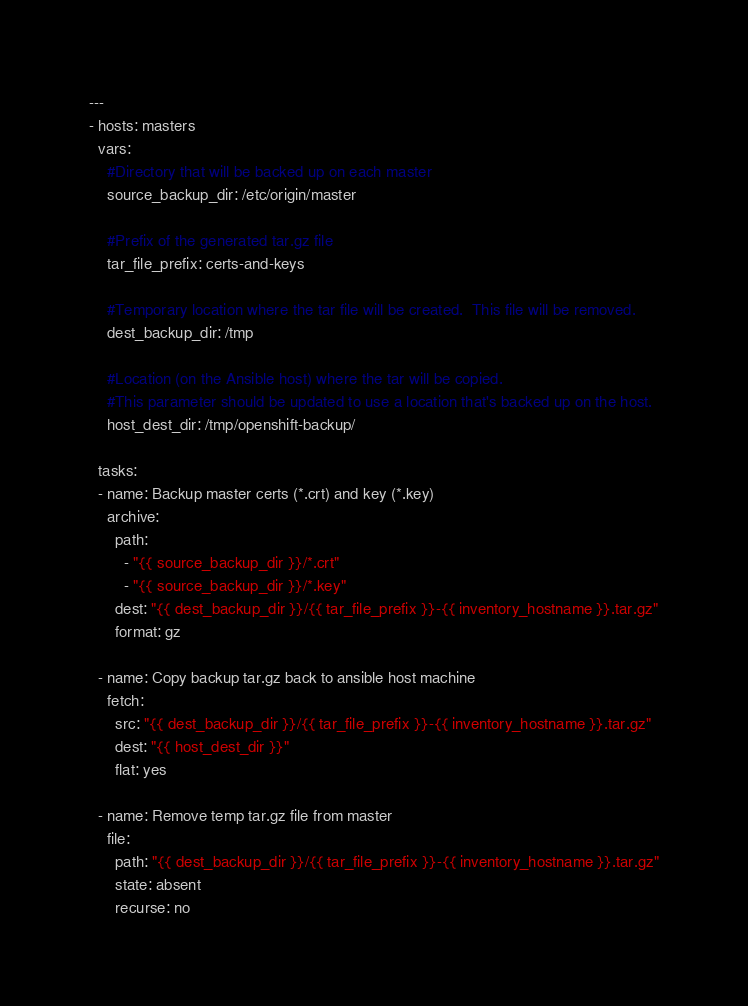Convert code to text. <code><loc_0><loc_0><loc_500><loc_500><_YAML_>---
- hosts: masters
  vars:
    #Directory that will be backed up on each master
    source_backup_dir: /etc/origin/master

    #Prefix of the generated tar.gz file
    tar_file_prefix: certs-and-keys

    #Temporary location where the tar file will be created.  This file will be removed.
    dest_backup_dir: /tmp

    #Location (on the Ansible host) where the tar will be copied.
    #This parameter should be updated to use a location that's backed up on the host.
    host_dest_dir: /tmp/openshift-backup/

  tasks:
  - name: Backup master certs (*.crt) and key (*.key)
    archive:
      path:
        - "{{ source_backup_dir }}/*.crt"
        - "{{ source_backup_dir }}/*.key"
      dest: "{{ dest_backup_dir }}/{{ tar_file_prefix }}-{{ inventory_hostname }}.tar.gz"
      format: gz

  - name: Copy backup tar.gz back to ansible host machine
    fetch:
      src: "{{ dest_backup_dir }}/{{ tar_file_prefix }}-{{ inventory_hostname }}.tar.gz"
      dest: "{{ host_dest_dir }}"
      flat: yes

  - name: Remove temp tar.gz file from master
    file:
      path: "{{ dest_backup_dir }}/{{ tar_file_prefix }}-{{ inventory_hostname }}.tar.gz"
      state: absent
      recurse: no
</code> 